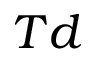<formula> <loc_0><loc_0><loc_500><loc_500>T d</formula> 